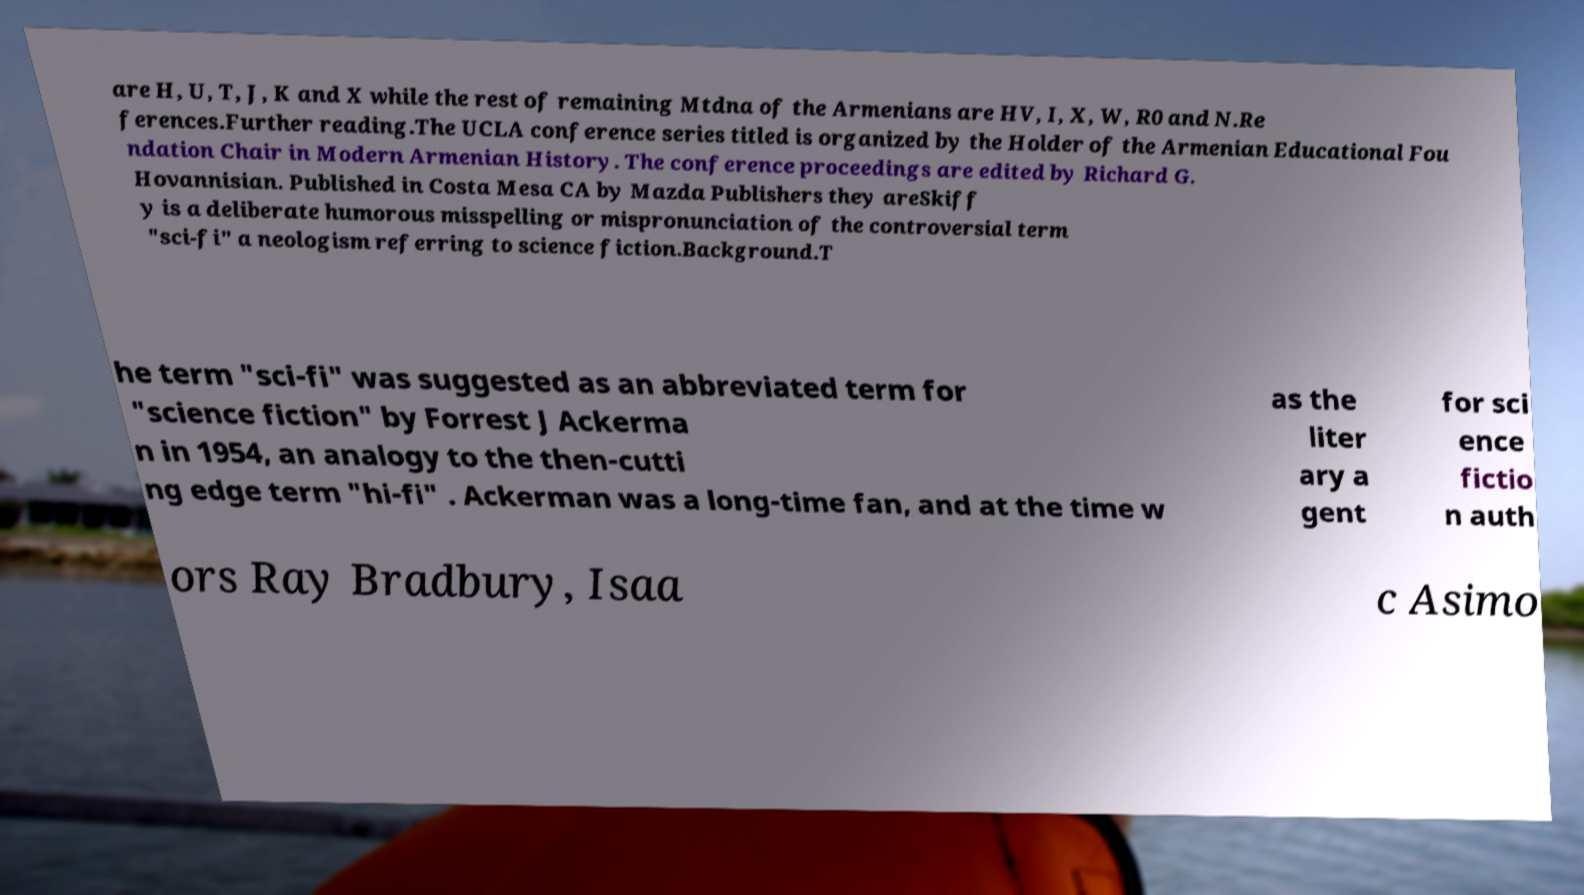Could you extract and type out the text from this image? are H, U, T, J, K and X while the rest of remaining Mtdna of the Armenians are HV, I, X, W, R0 and N.Re ferences.Further reading.The UCLA conference series titled is organized by the Holder of the Armenian Educational Fou ndation Chair in Modern Armenian History. The conference proceedings are edited by Richard G. Hovannisian. Published in Costa Mesa CA by Mazda Publishers they areSkiff y is a deliberate humorous misspelling or mispronunciation of the controversial term "sci-fi" a neologism referring to science fiction.Background.T he term "sci-fi" was suggested as an abbreviated term for "science fiction" by Forrest J Ackerma n in 1954, an analogy to the then-cutti ng edge term "hi-fi" . Ackerman was a long-time fan, and at the time w as the liter ary a gent for sci ence fictio n auth ors Ray Bradbury, Isaa c Asimo 